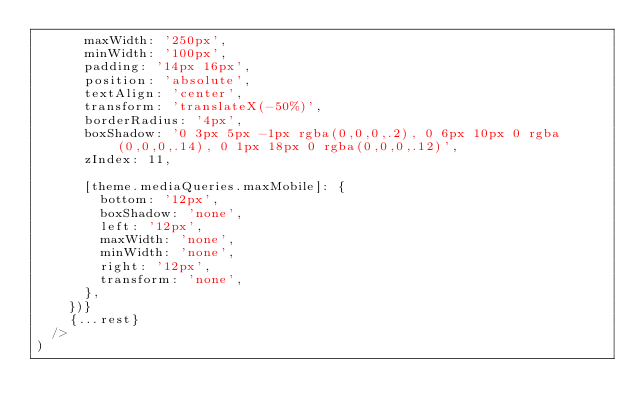Convert code to text. <code><loc_0><loc_0><loc_500><loc_500><_TypeScript_>			maxWidth: '250px',
			minWidth: '100px',
			padding: '14px 16px',
			position: 'absolute',
			textAlign: 'center',
			transform: 'translateX(-50%)',
			borderRadius: '4px',
			boxShadow: '0 3px 5px -1px rgba(0,0,0,.2), 0 6px 10px 0 rgba(0,0,0,.14), 0 1px 18px 0 rgba(0,0,0,.12)',
			zIndex: 11,

			[theme.mediaQueries.maxMobile]: {
				bottom: '12px',
				boxShadow: 'none',
				left: '12px',
				maxWidth: 'none',
				minWidth: 'none',
				right: '12px',
				transform: 'none',
			},
		})}
		{...rest}
	/>
)
</code> 